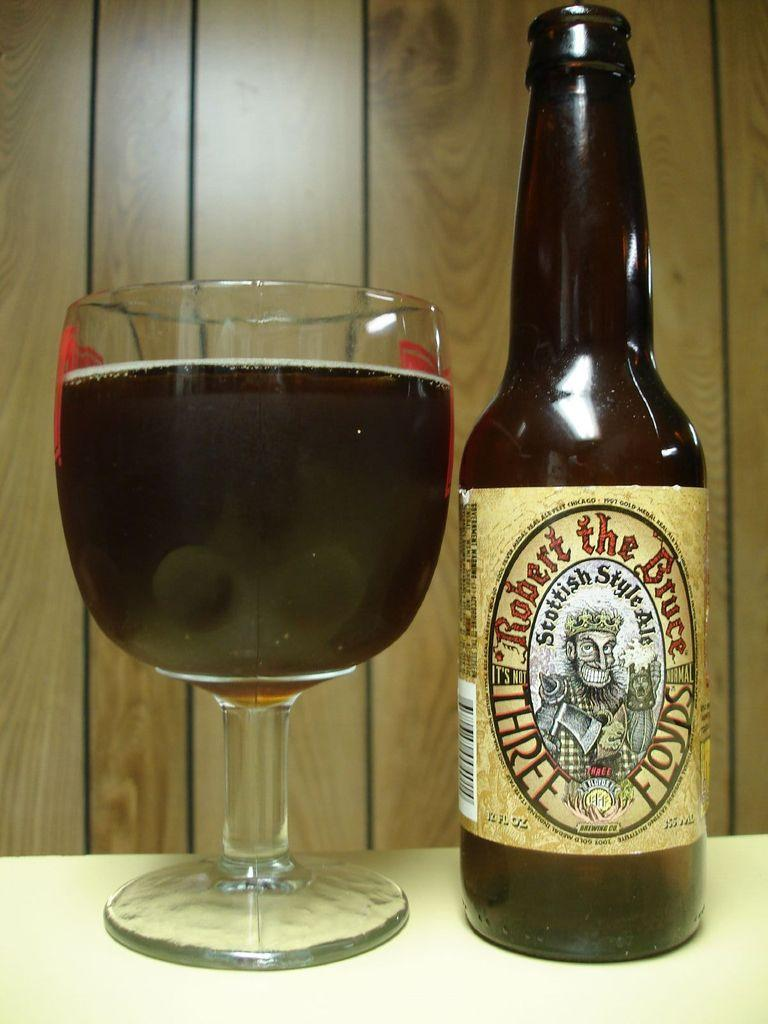<image>
Summarize the visual content of the image. A glass and a bottle filled with Robert the Bruce Ale sitting on a table. 